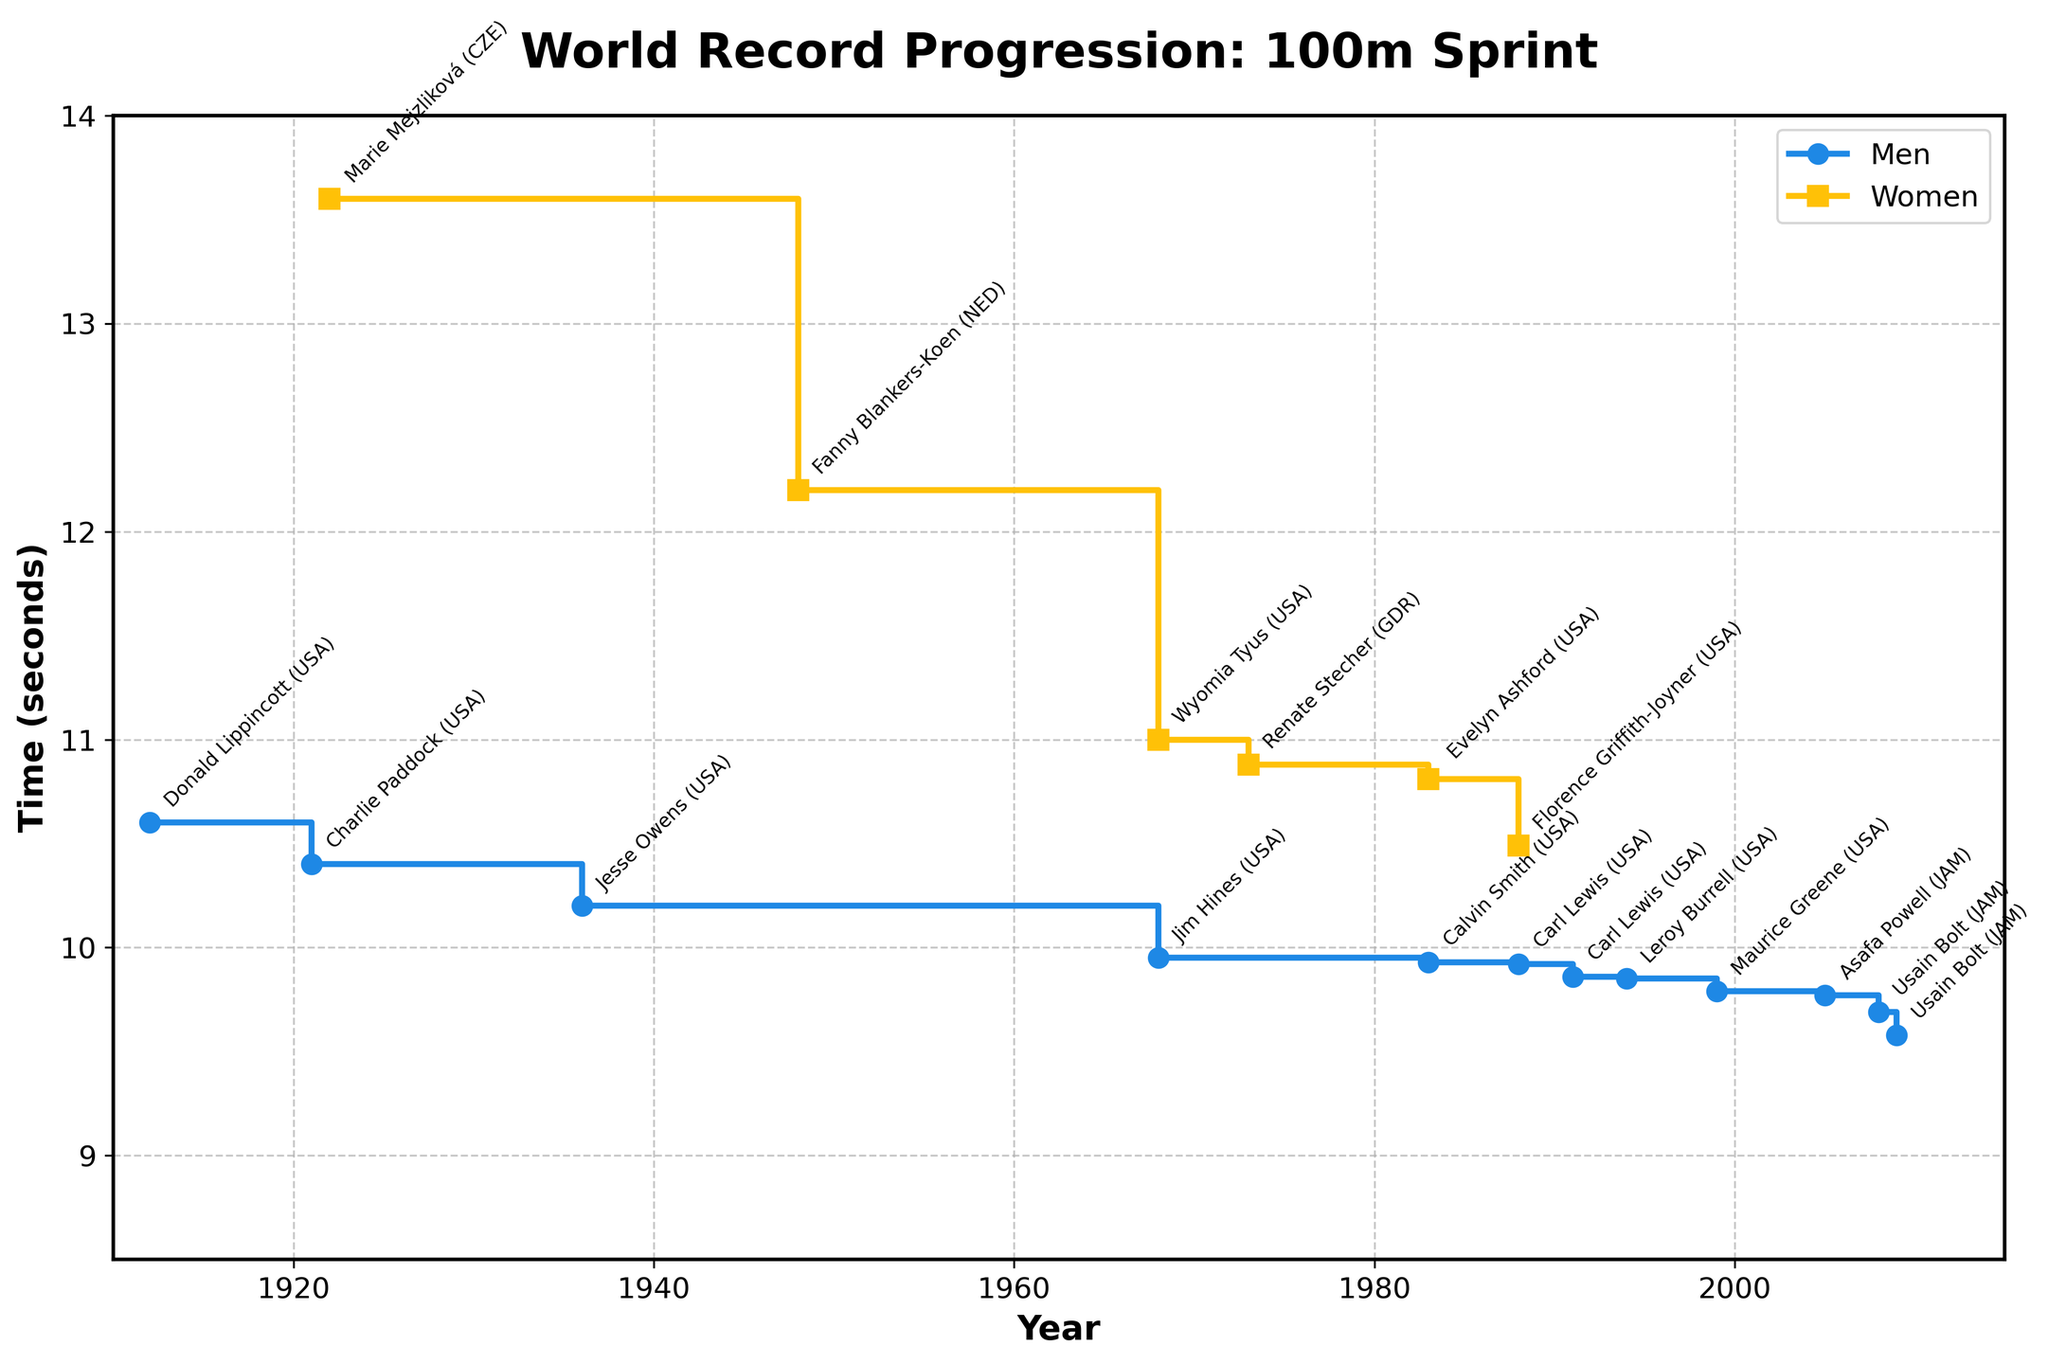What is the title of the plot? The title of the plot is typically displayed at the top of the figure. In this case, it is "World Record Progression: 100m Sprint".
Answer: World Record Progression: 100m Sprint How many data points are there for men? Count the number of circles along the line representing men in the plot, each corresponds to a record update. There are 12 data points for men.
Answer: 12 Who achieved the first recorded women's 100m sprint time in the dataset? Identify the leftmost point on the women's (yellow squares) line, annotated by the athlete's name. The first recorded women's 100m sprint time was achieved by Marie Mejzliková.
Answer: Marie Mejzliková By how much did Usain Bolt improve the world record between 2008 and 2009? Find Usain Bolt's records in the plot (the two data points he set). The times are 9.69s in 2008 and 9.58s in 2009. The difference is 9.69 - 9.58 = 0.11 seconds.
Answer: 0.11 seconds What was the world record time for men in the 100m sprint just before 1968? Look at the record time for men right before the 1968 reduction (blue circles). The time just before 1968 was 10.2 seconds set in 1936 by Jesse Owens.
Answer: 10.2 seconds Which athlete from Jamaica set the men's 100m world record and when did he set it? Identify the Jamaican athlete in the annotations along the men’s (blue circles) line. Asafa Powell set a record in 2005, and Usain Bolt set records in 2008 and 2009.
Answer: Asafa Powell (2005), Usain Bolt (2008, 2009) What was the reduction in the women's 100m world record after Fanny Blankers-Koen's record in 1948? Identify the next improvement after 1948 on the women’s (yellow squares) line, which was in 1968 by Wyomia Tyus. The times are 12.2s in 1948 and 11.0s in 1968. The difference is 12.2 - 11.0 = 1.2 seconds.
Answer: 1.2 seconds Have there been more world record improvements in men's or women's 100m sprints according to the plot? Count the number of steps or data points along each line (men and women). Men have 12 data points, and women have 6 data points. Men have more improvements.
Answer: Men What is the average world record time for women's 100m sprint from the given data? Add up all the record times for women: 13.6 + 12.2 + 11.0 + 10.88 + 10.81 + 10.49, and then divide by the number of records (6). (13.6 + 12.2 + 11.0 + 10.88 + 10.81 + 10.49)/6 = 69.98/6 ≈ 11.663 seconds.
Answer: 11.663 seconds How did the men's 100m record time progress between 1968 and 1988? Look at the data points for men's records between 1968 and 1988. The records in 1968, 1983, and 1988 are 9.95s, 9.93s, and 9.92s respectively.
Answer: 9.95s to 9.93s to 9.92s 